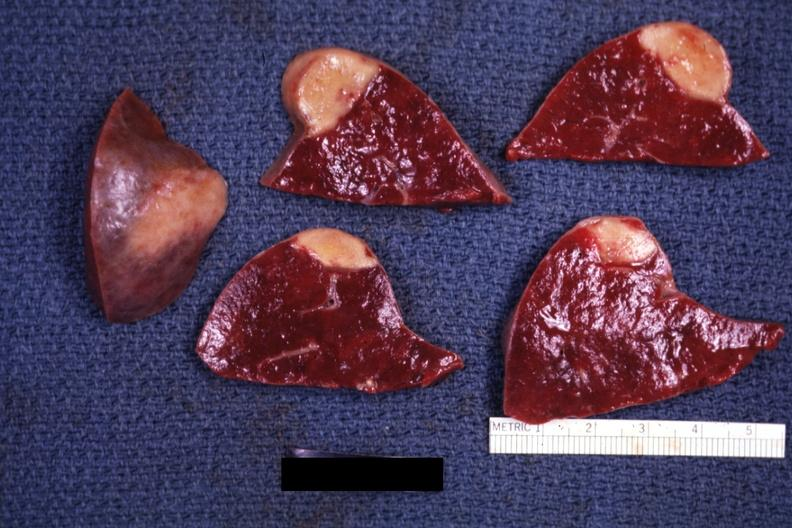s infant body present?
Answer the question using a single word or phrase. No 